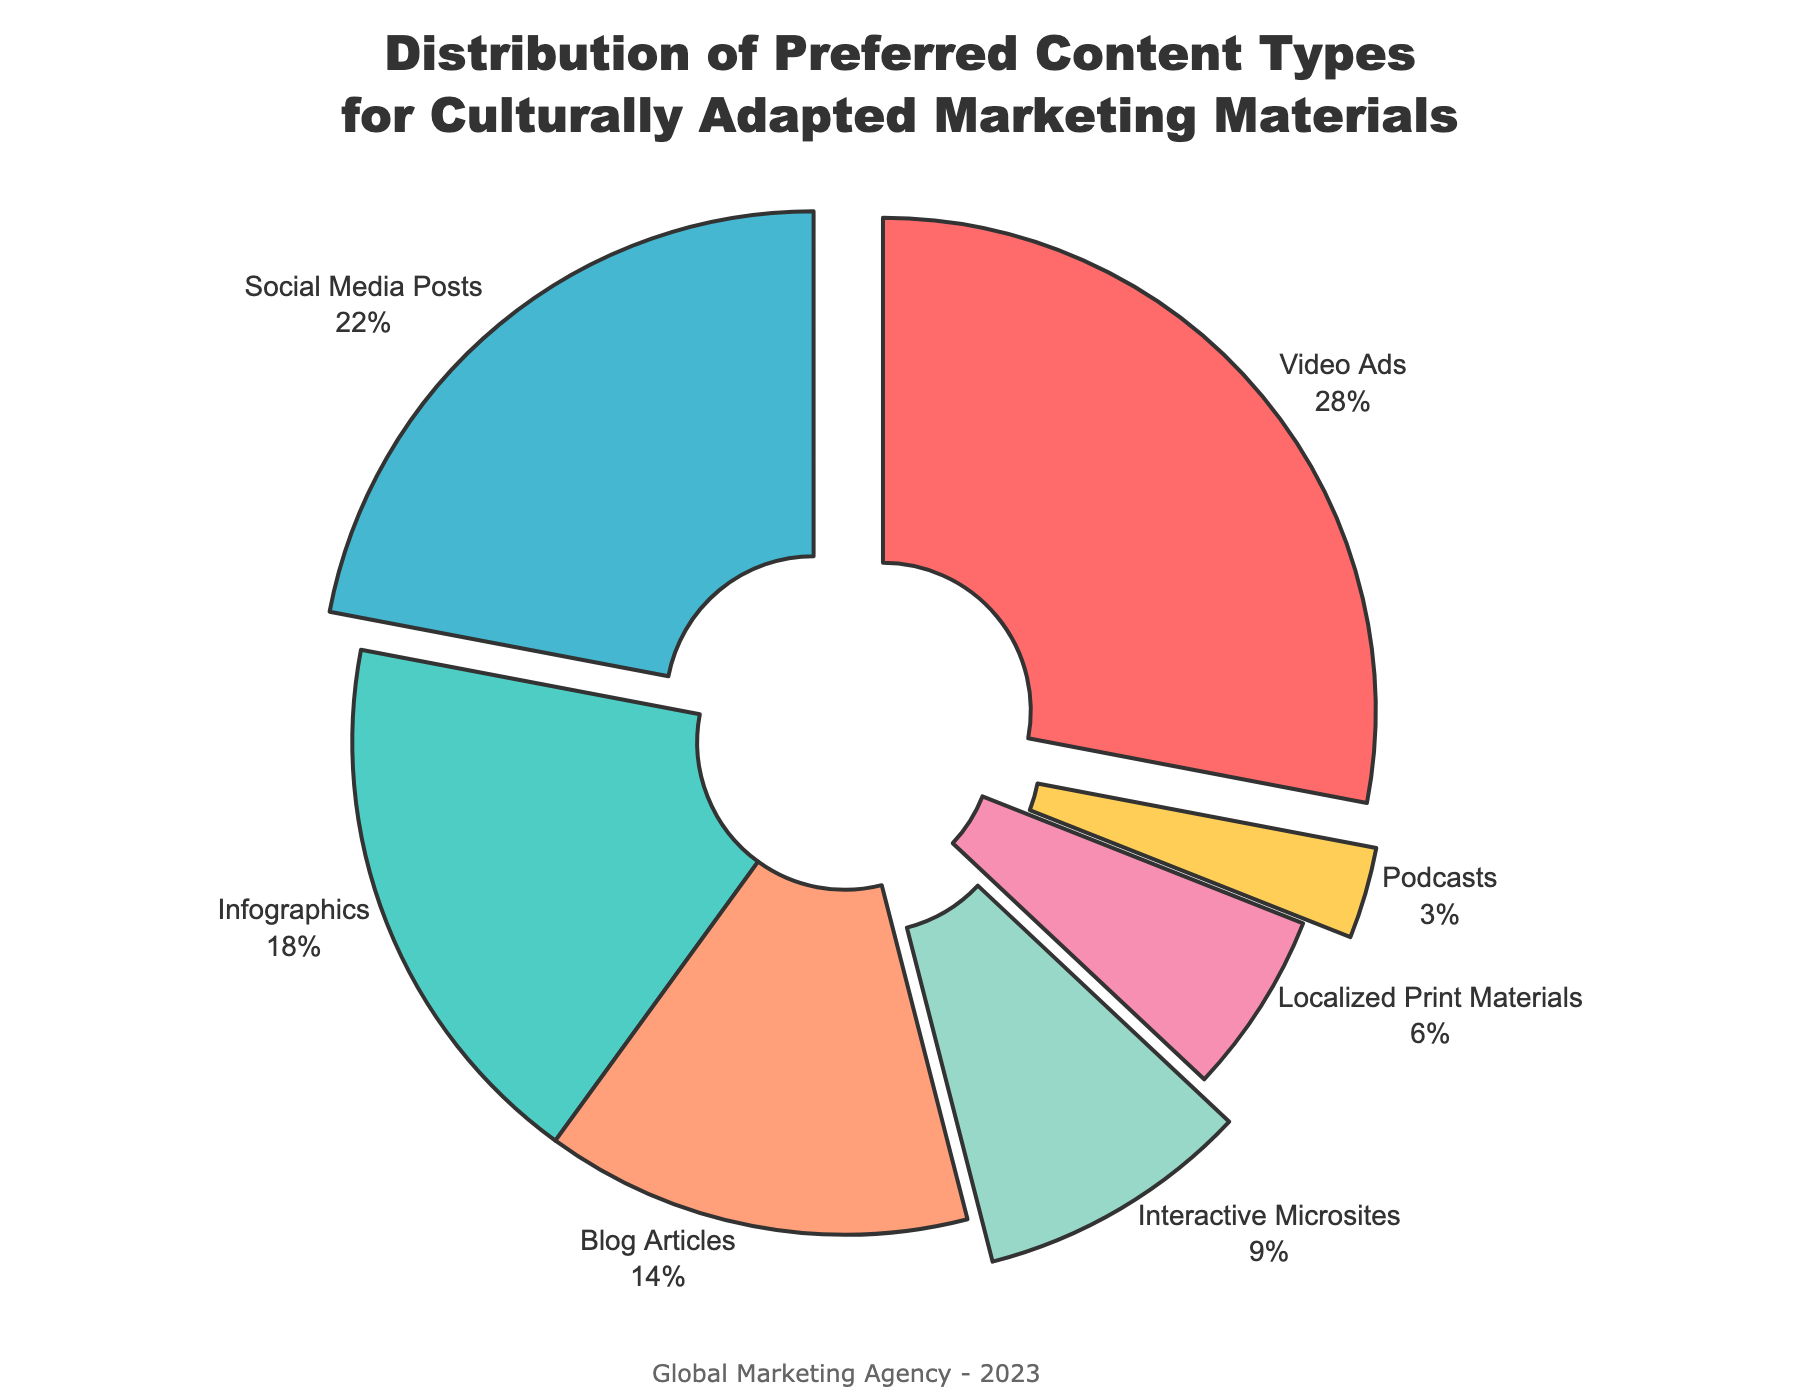What's the most preferred content type for culturally adapted marketing materials? The figure shows that 'Video Ads' has the highest percentage share among all the content types presented. This can be identified because it has the largest segment in the pie chart.
Answer: Video Ads How much percentage do Infographics and Social Media Posts collectively contribute? To find the combined percentage, we add the percentage share of Infographics and Social Media Posts, which are 18% and 22% respectively. So, 18 + 22 = 40%.
Answer: 40% Which content type is the least preferred for culturally adapted marketing materials? The least preferred content type can be identified by looking for the smallest segment in the pie chart. 'Podcasts' has the smallest percentage share.
Answer: Podcasts Is the share of Blog Articles higher or lower than that of Interactive Microsites? By comparing the size of segments in the pie chart, we observe that 'Blog Articles' has 14% while 'Interactive Microsites' has 9%. Thus, Blog Articles have a higher percentage than Interactive Microsites.
Answer: Higher What is the combined percentage of Video Ads and Localized Print Materials? Adding the percentage share of Video Ads and Localized Print Materials gives us 28% + 6% = 34%.
Answer: 34% Which two content types have the closest percentage shares? By examining the pie chart, we see that 'Infographics' (18%) and 'Social Media Posts' (22%) have the closest percentage shares with a difference of 4%.
Answer: Infographics and Social Media Posts How much more preferred are Social Media Posts compared to Interactive Microsites? The difference in preference is calculated by subtracting the percentage share of Interactive Microsites from Social Media Posts, i.e., 22% - 9% = 13%.
Answer: 13% What is the total percentage of content types that have a share of 10% or less? The content types with shares of 10% or less are Interactive Microsites (9%), Localized Print Materials (6%), and Podcasts (3%). Summing these percentages gives 9 + 6 + 3 = 18%.
Answer: 18% If we omit the most preferred content type, what is the new total percentage represented by the remaining content types? The most preferred content type is Video Ads with 28%. The total must be 100% - 28% = 72%, which is the combined share of the remaining content types.
Answer: 72% 